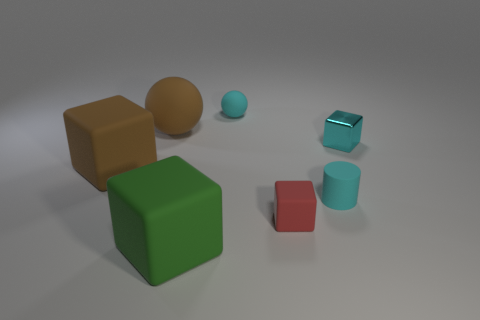There is a small sphere on the right side of the block that is left of the green object; what is its color? The small sphere positioned to the right of the block, which is situated to the left of the green cube, exhibits a cyan hue. 